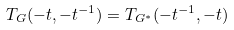Convert formula to latex. <formula><loc_0><loc_0><loc_500><loc_500>T _ { G } ( - t , - t ^ { - 1 } ) = T _ { G ^ { \ast } } ( - t ^ { - 1 } , - t )</formula> 